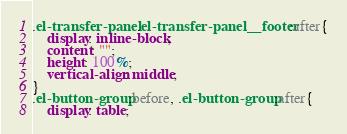Convert code to text. <code><loc_0><loc_0><loc_500><loc_500><_CSS_>.el-transfer-panel .el-transfer-panel__footer:after{
    display: inline-block;
    content: "";
    height: 100%;
    vertical-align: middle;
}
.el-button-group:before, .el-button-group:after{
    display: table;</code> 